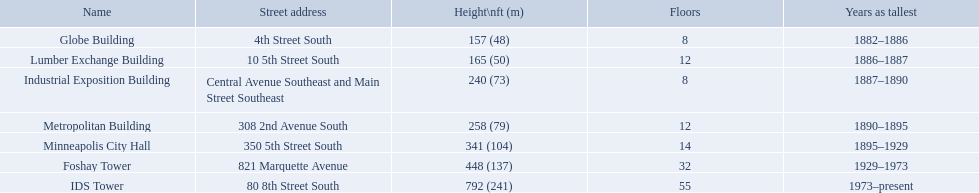Which buildings have the same number of floors as another building? Globe Building, Lumber Exchange Building, Industrial Exposition Building, Metropolitan Building. Of those, which has the same as the lumber exchange building? Metropolitan Building. What years was 240 ft considered tall? 1887–1890. What building held this record? Industrial Exposition Building. What are the tallest buildings in minneapolis? Globe Building, Lumber Exchange Building, Industrial Exposition Building, Metropolitan Building, Minneapolis City Hall, Foshay Tower, IDS Tower. What is the height of the metropolitan building? 258 (79). What is the height of the lumber exchange building? 165 (50). Of those two which is taller? Metropolitan Building. Would you be able to parse every entry in this table? {'header': ['Name', 'Street address', 'Height\\nft (m)', 'Floors', 'Years as tallest'], 'rows': [['Globe Building', '4th Street South', '157 (48)', '8', '1882–1886'], ['Lumber Exchange Building', '10 5th Street South', '165 (50)', '12', '1886–1887'], ['Industrial Exposition Building', 'Central Avenue Southeast and Main Street Southeast', '240 (73)', '8', '1887–1890'], ['Metropolitan Building', '308 2nd Avenue South', '258 (79)', '12', '1890–1895'], ['Minneapolis City Hall', '350 5th Street South', '341 (104)', '14', '1895–1929'], ['Foshay Tower', '821 Marquette Avenue', '448 (137)', '32', '1929–1973'], ['IDS Tower', '80 8th Street South', '792 (241)', '55', '1973–present']]} What are the tallest buildings in minneapolis? Globe Building, Lumber Exchange Building, Industrial Exposition Building, Metropolitan Building, Minneapolis City Hall, Foshay Tower, IDS Tower. Which of those have 8 floors? Globe Building, Industrial Exposition Building. Of those, which is 240 ft tall? Industrial Exposition Building. 